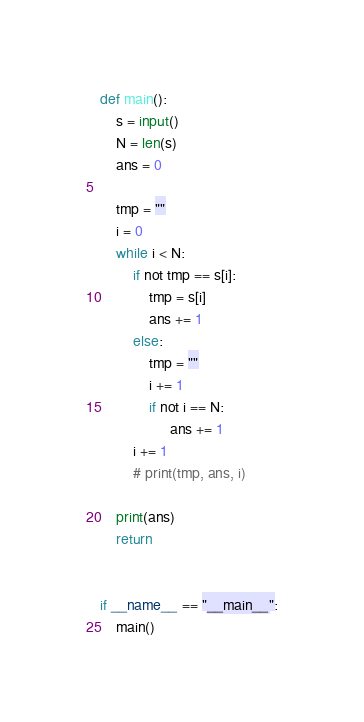Convert code to text. <code><loc_0><loc_0><loc_500><loc_500><_Python_>def main():
    s = input()
    N = len(s)
    ans = 0

    tmp = ""
    i = 0
    while i < N:
        if not tmp == s[i]:
            tmp = s[i]
            ans += 1
        else:
            tmp = ""
            i += 1
            if not i == N:
                 ans += 1
        i += 1
        # print(tmp, ans, i)

    print(ans)
    return


if __name__ == "__main__":
    main()</code> 